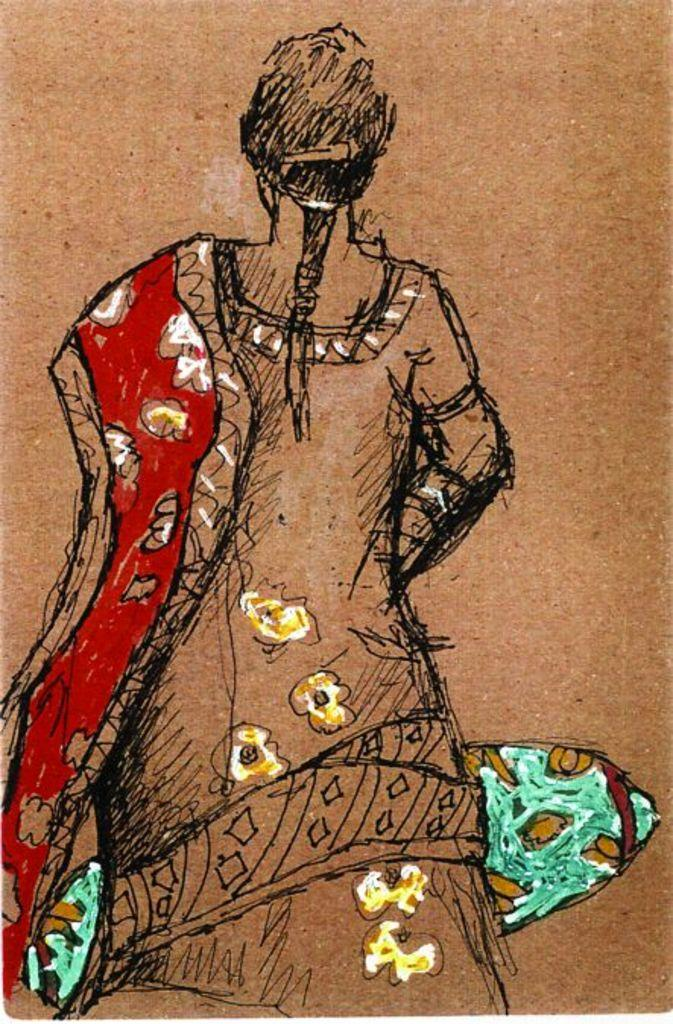What is depicted in the image? There is a sketch of a woman in the image. Where is the sketch located? The sketch is on the surface of the image. What is the chance of the woman in the sketch taking any action in the image? The chance of the woman in the sketch taking any action is not applicable, as the image is a static sketch and not a depiction of a real-life scenario. 